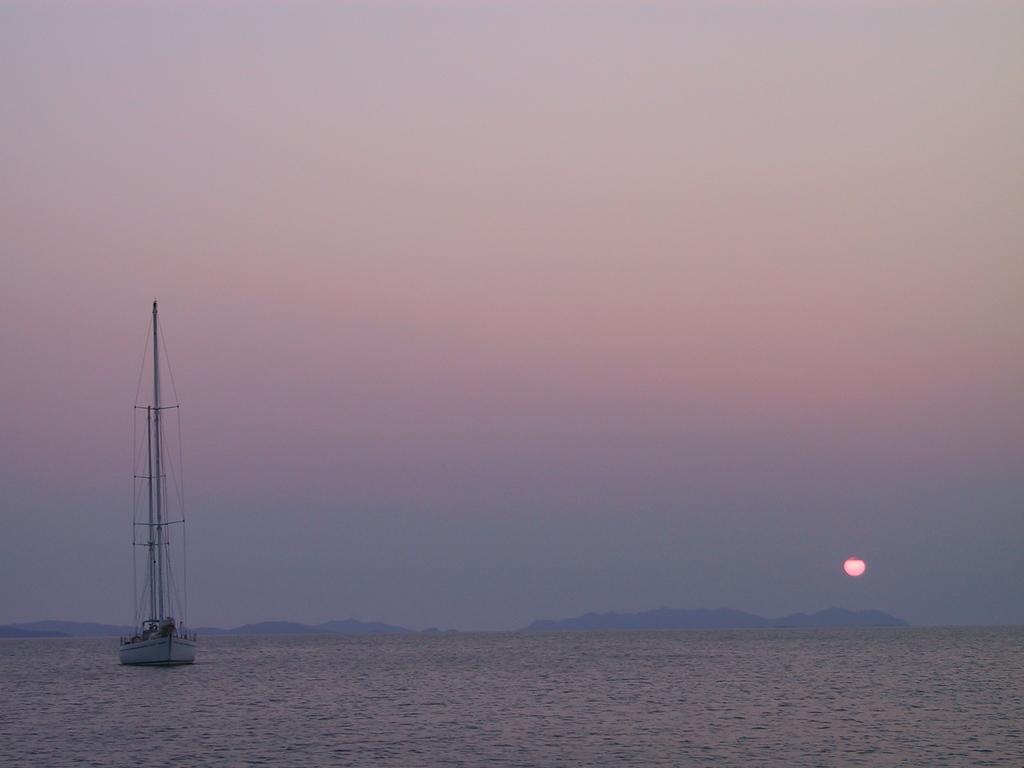Please provide a concise description of this image. In this image I can see a boat which is white in color on the surface of the water. In the background I can see few mountains, the sky and the sun. 